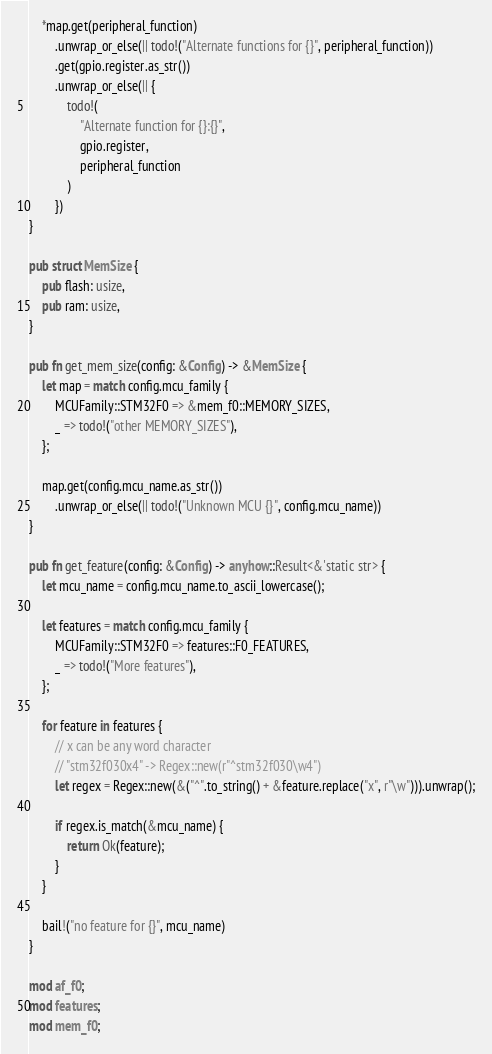Convert code to text. <code><loc_0><loc_0><loc_500><loc_500><_Rust_>
    *map.get(peripheral_function)
        .unwrap_or_else(|| todo!("Alternate functions for {}", peripheral_function))
        .get(gpio.register.as_str())
        .unwrap_or_else(|| {
            todo!(
                "Alternate function for {}:{}",
                gpio.register,
                peripheral_function
            )
        })
}

pub struct MemSize {
    pub flash: usize,
    pub ram: usize,
}

pub fn get_mem_size(config: &Config) -> &MemSize {
    let map = match config.mcu_family {
        MCUFamily::STM32F0 => &mem_f0::MEMORY_SIZES,
        _ => todo!("other MEMORY_SIZES"),
    };

    map.get(config.mcu_name.as_str())
        .unwrap_or_else(|| todo!("Unknown MCU {}", config.mcu_name))
}

pub fn get_feature(config: &Config) -> anyhow::Result<&'static str> {
    let mcu_name = config.mcu_name.to_ascii_lowercase();

    let features = match config.mcu_family {
        MCUFamily::STM32F0 => features::F0_FEATURES,
        _ => todo!("More features"),
    };

    for feature in features {
        // x can be any word character
        // "stm32f030x4" -> Regex::new(r"^stm32f030\w4")
        let regex = Regex::new(&("^".to_string() + &feature.replace("x", r"\w"))).unwrap();

        if regex.is_match(&mcu_name) {
            return Ok(feature);
        }
    }

    bail!("no feature for {}", mcu_name)
}

mod af_f0;
mod features;
mod mem_f0;
</code> 